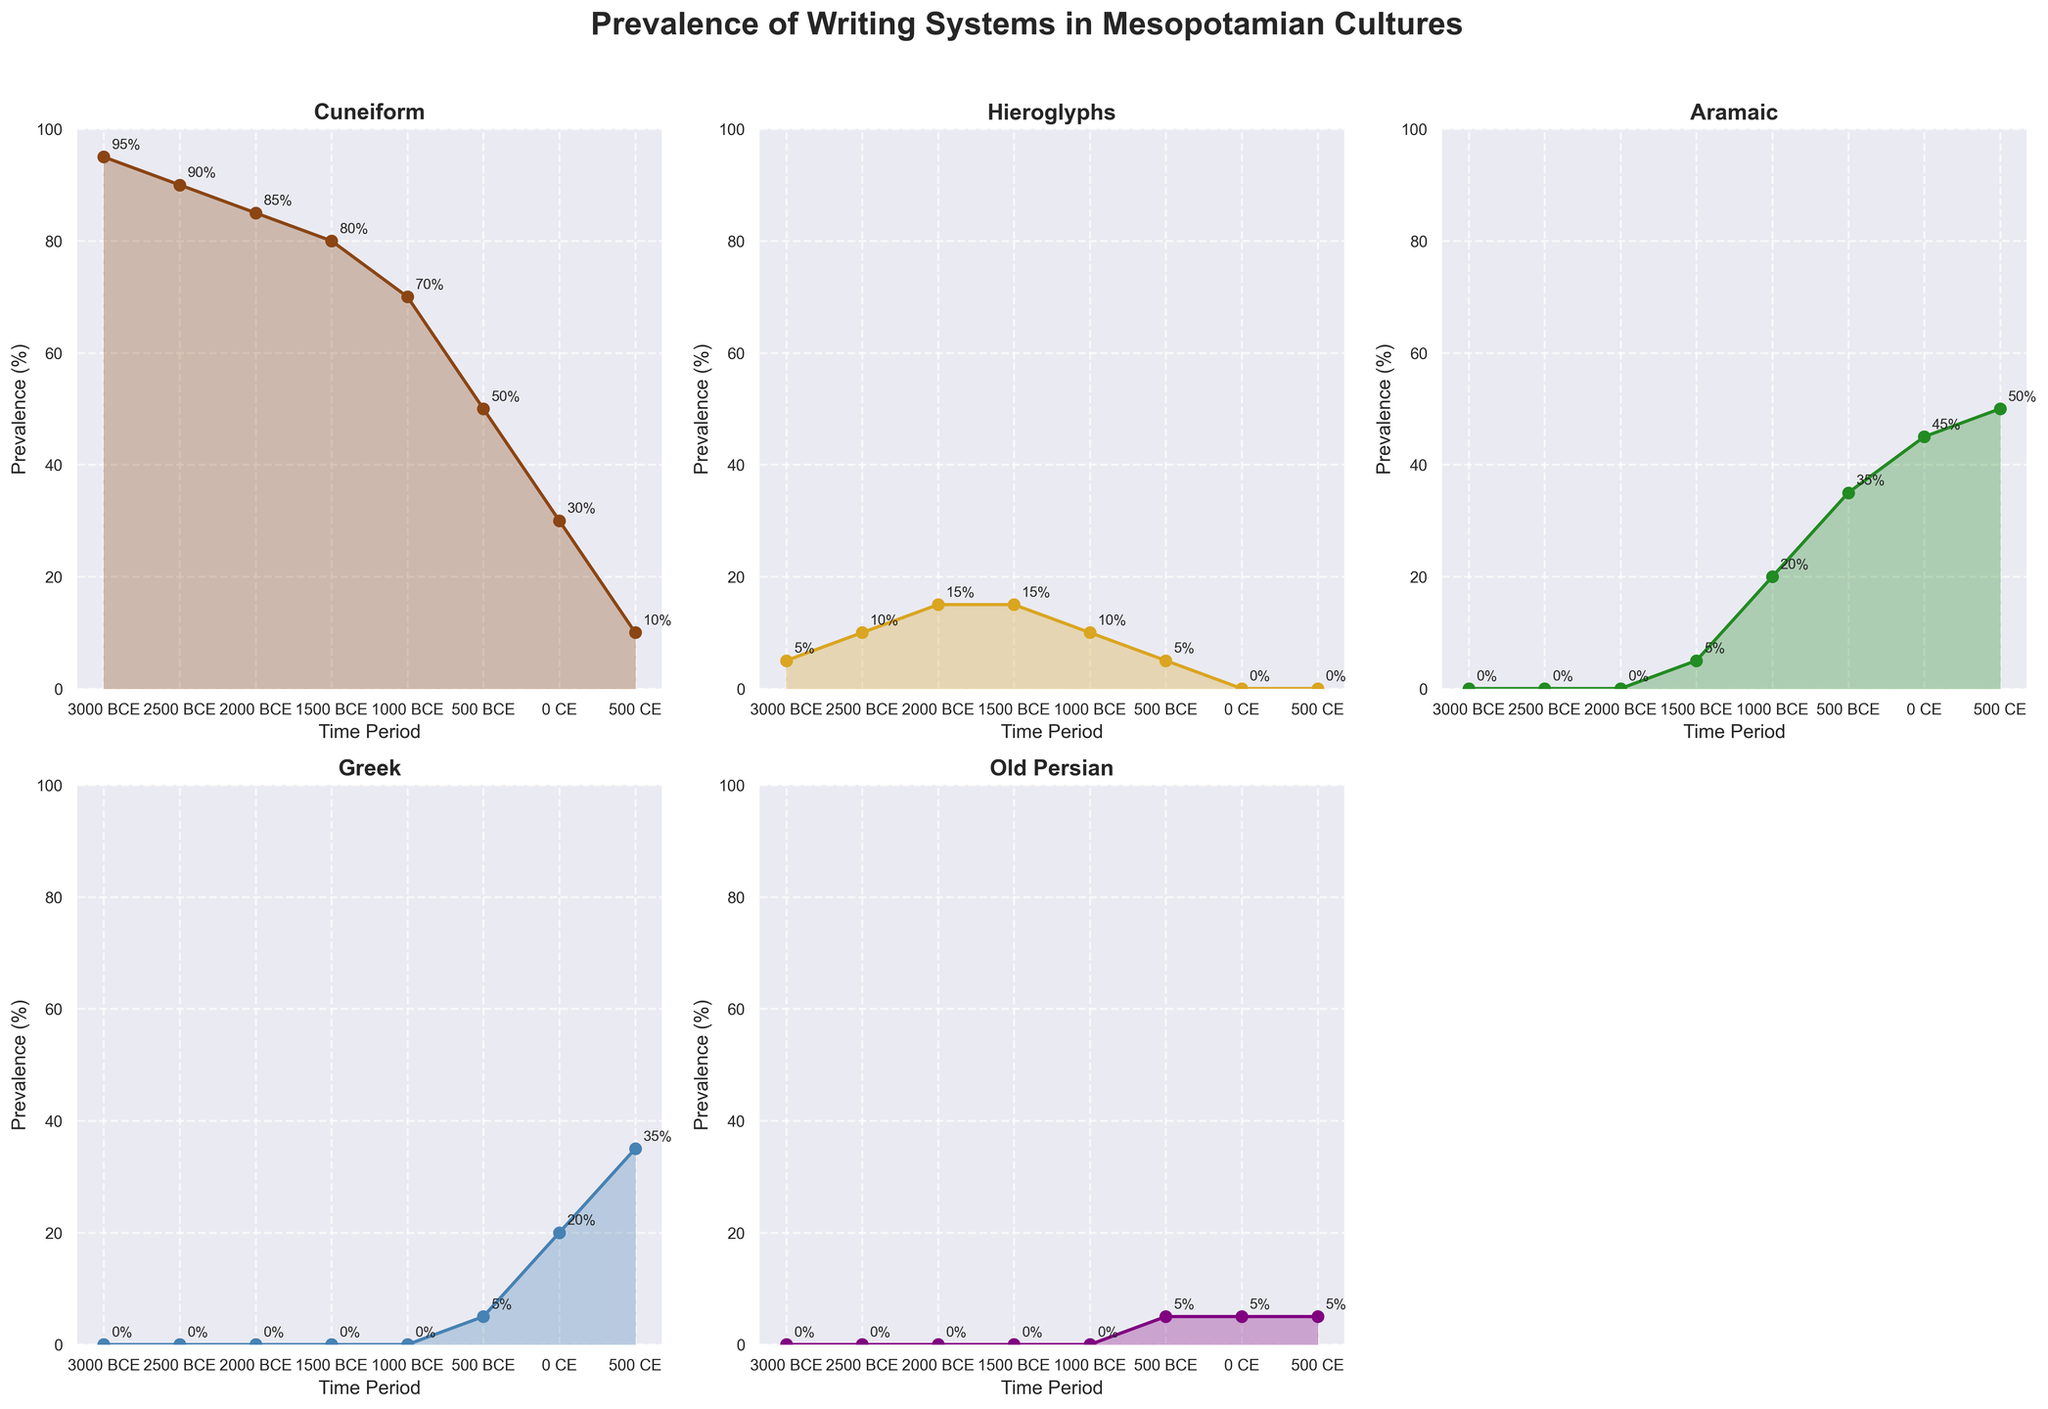What is the title of the figure? The title is usually placed prominently at the top of a figure or graph. In this figure, it is clearly displayed above the plots.
Answer: "Prevalence of Writing Systems in Mesopotamian Cultures" Which writing system had the highest prevalence in 2000 BCE? By examining the values for each writing system at the "2000 BCE" time point, we note the highest percentage value.
Answer: Cuneiform How does the prevalence of Greek change from 500 BCE to 0 CE? Look at the Greek subplot and compare the prevalence values at 500 BCE and 0 CE. The value at 500 BCE is 5%, and at 0 CE it is 20%, showing an increase.
Answer: It increases by 15% Which time period saw the decline of Cuneiform below 50%? Review the Cuneiform subplot and find the time period when its prevalence drops below 50%. It happens at the "500 BCE" data point.
Answer: 500 BCE Compare the prevalence of Hieroglyphs and Aramaic in 1000 BCE. Which one is more prevalent? Check the subplots for Hieroglyphs and Aramaic in 1000 BCE. Hieroglyphs have a prevalence of 10%, while Aramaic is at 20%.
Answer: Aramaic What trend do you observe in the prevalence of Cuneiform from 3000 BCE to 500 CE? Identify the general direction of the Cuneiform values over time. The values show a continuous decline.
Answer: Continuous decline During which period did Old Persian have the same prevalence as Hieroglyphs? Compare the values of Old Persian and Hieroglyphs across the periods. Both have a prevalence of 5% at 500 BCE.
Answer: 500 BCE What is the combined prevalence of Aramaic and Greek in 500 CE? Find the values for Aramaic and Greek in 500 CE, then add them together: Aramaic (50%) + Greek (35%) = 85%.
Answer: 85% Which writing system remained constant in prevalence for the longest period? Look at each subplot to identify the writing system with the longest duration of unchanged values. Hieroglyphs remained at 5% from 3000 BCE to 1500 BCE.
Answer: Hieroglyphs By how much did the prevalence of Cuneiform decrease from 3000 BCE to 0 CE? Compare the prevalence of Cuneiform at 3000 BCE (95%) and 0 CE (30%), then calculate the difference: 95% - 30% = 65%.
Answer: 65% 